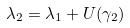Convert formula to latex. <formula><loc_0><loc_0><loc_500><loc_500>\lambda _ { 2 } = \lambda _ { 1 } + U ( \gamma _ { 2 } )</formula> 